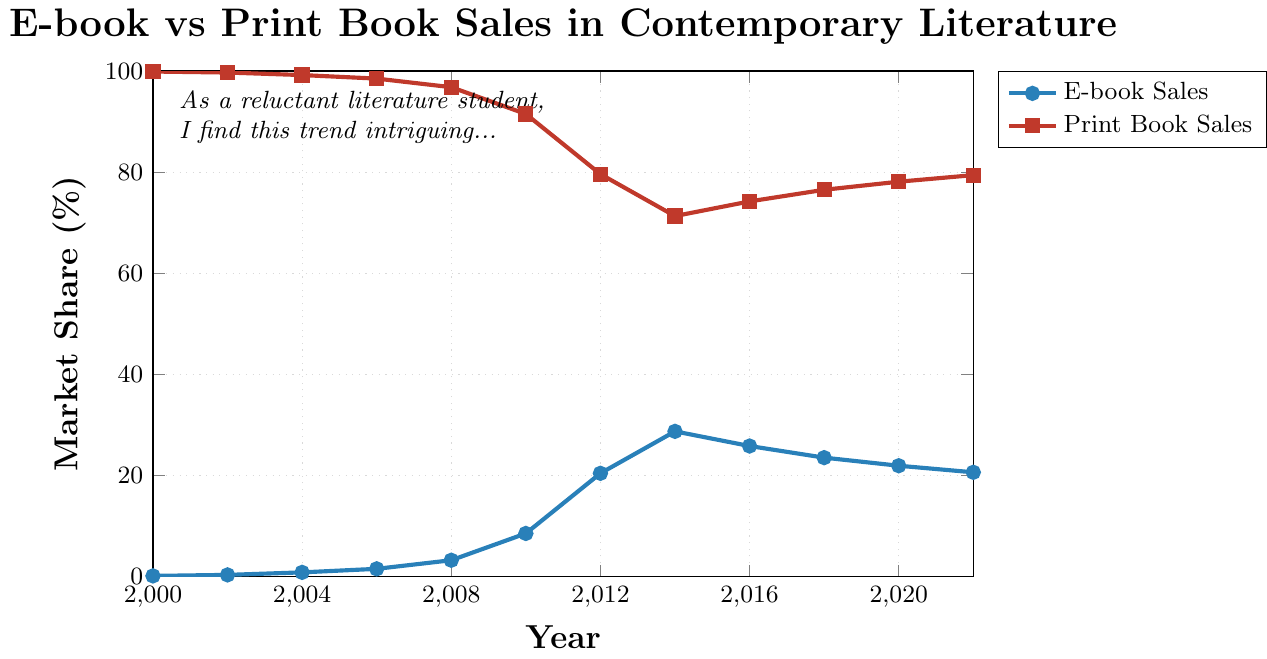What's the peak value for E-book sales and when did it occur? To find the peak value for E-book sales, look for the highest point on the E-book Sales line. This peak occurs at 28.7% in the year 2014.
Answer: 28.7% in 2014 Which year saw the largest difference in market share between E-book and Print book sales? Calculate the difference between E-book and Print book sales for each year, then find the year with the largest difference. The year 2012 has the largest difference of 59.2% (79.6% - 20.4%).
Answer: 2012 How did E-book sales trend overall from 2000 to 2022? Observe the overall direction of the E-book Sales line from 2000 to 2022. It shows an increasing trend until 2014, then a slight decline but remains higher than initial values.
Answer: Increased until 2014, then slight decline In which year did E-book sales surpass 20% market share? Locate the E-book Sales line and find the first year after 2000 where the value exceeds 20%. This occurs in 2012 when E-book sales reach 20.4%.
Answer: 2012 Compare the E-book and Print book sales between 2014 and 2022. For comparison, note the values for both E-book and Print book sales in these years. 2014: E-book 28.7%, Print 71.3%; 2022: E-book 20.6%, Print 79.4%. E-book sales decreased while Print book sales increased from 2014 to 2022.
Answer: E-book decreased, Print increased What is the average market share of E-book sales from 2000 to 2010? Add the E-book sales percentages for the given years and divide by the number of years: (0.1 + 0.3 + 0.8 + 1.5 + 3.2 + 8.5) / 6 = 14.4 / 6 = 2.4%.
Answer: 2.4% By how much did Print book sales decline from 2000 to 2012? Subtract the Print book sales percentage in 2012 from the percentage in 2000: 99.9% - 79.6% = 20.3%.
Answer: 20.3% In which year did E-book and Print book sales get closest in market share? Find the year with the smallest difference between E-book and Print book sales by comparing percentages. In 2014, the difference is the smallest at 42.6% (71.3% - 28.7%).
Answer: 2014 Did E-book sales ever dip after reaching 20% market share? Check if there are any years following 2012 where E-book sales fall below 20%. From the data, E-book sales remain above 20% until a drop in 2022 to 20.6%.
Answer: No How did Print book sales change from 2000 to 2022? Observe the direction and changes in the Print book Sales line from 2000 to 2022. There is a general decline over the years with slight fluctuations upward after 2014, ending at 79.4% in 2022.
Answer: Declined overall 